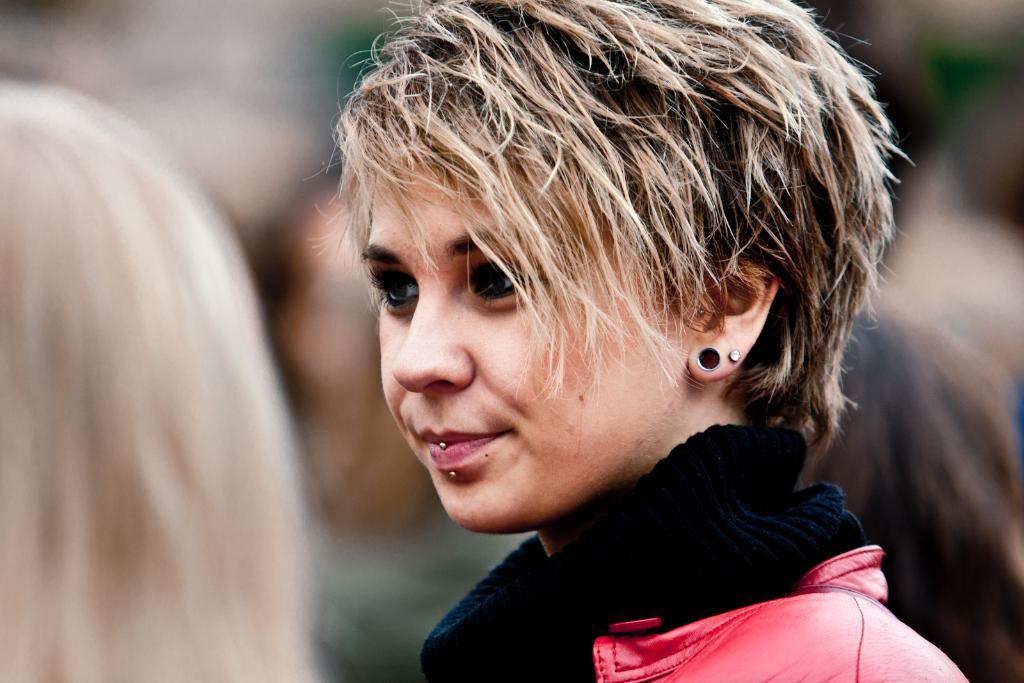Can you describe this image briefly? In this image there is one girl wearing black color dress with a jacket and some persons are in the background. 